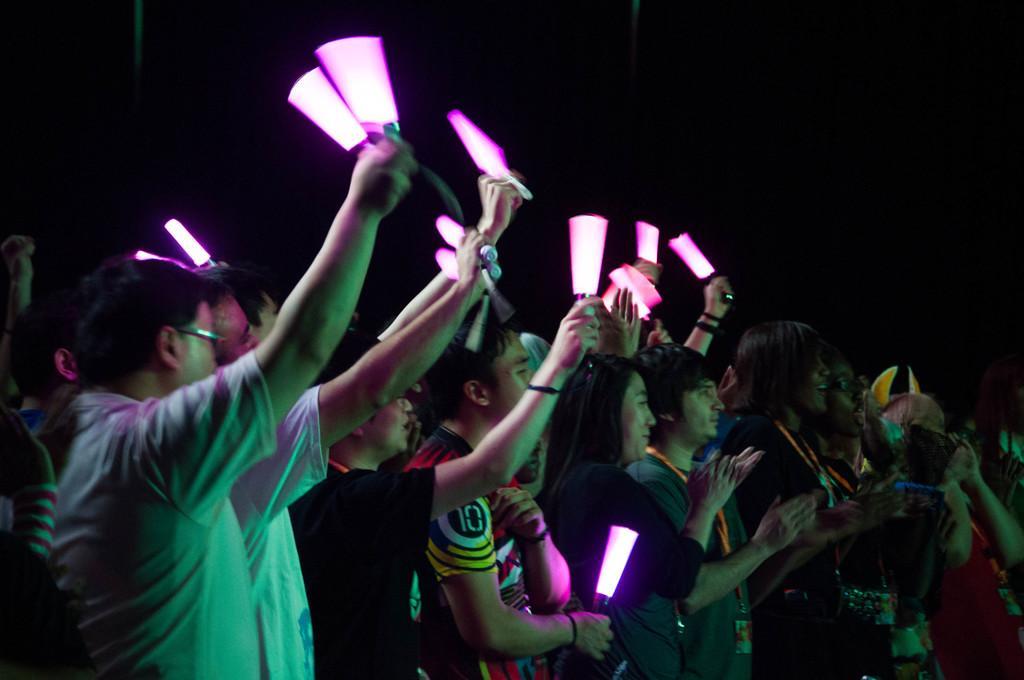How would you summarize this image in a sentence or two? In this picture there are people, among them few people holding lights. In the background of the image it is dark. 